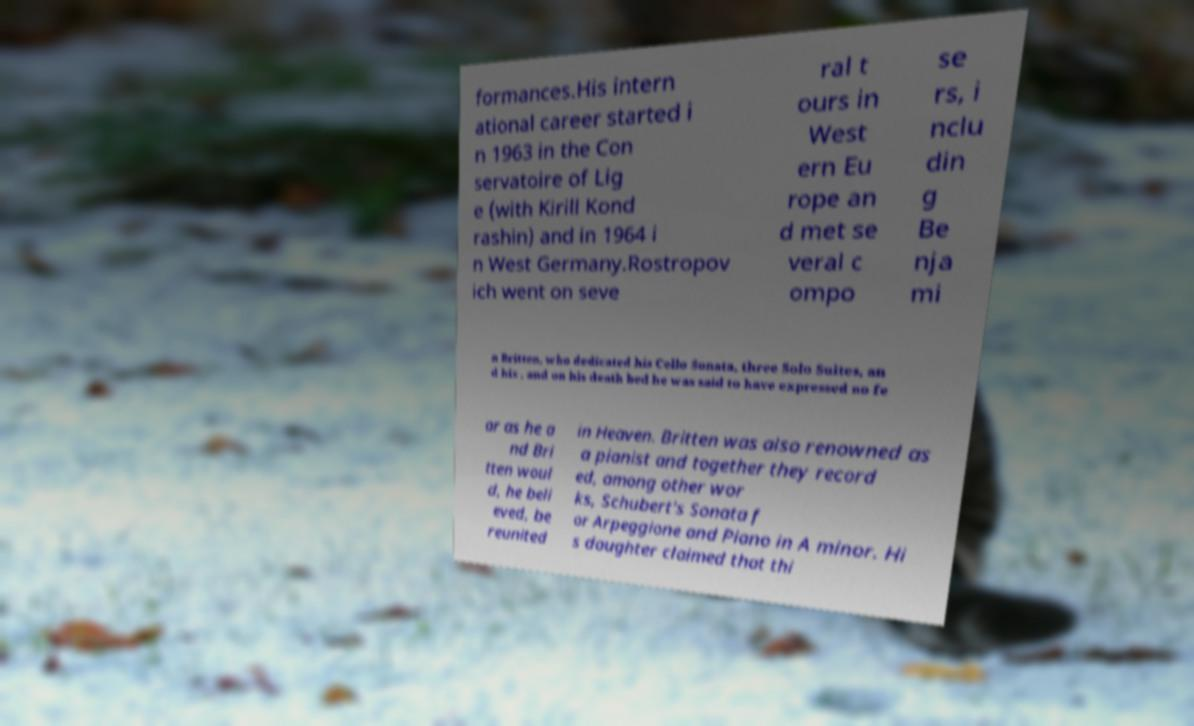I need the written content from this picture converted into text. Can you do that? formances.His intern ational career started i n 1963 in the Con servatoire of Lig e (with Kirill Kond rashin) and in 1964 i n West Germany.Rostropov ich went on seve ral t ours in West ern Eu rope an d met se veral c ompo se rs, i nclu din g Be nja mi n Britten, who dedicated his Cello Sonata, three Solo Suites, an d his , and on his death bed he was said to have expressed no fe ar as he a nd Bri tten woul d, he beli eved, be reunited in Heaven. Britten was also renowned as a pianist and together they record ed, among other wor ks, Schubert's Sonata f or Arpeggione and Piano in A minor. Hi s daughter claimed that thi 